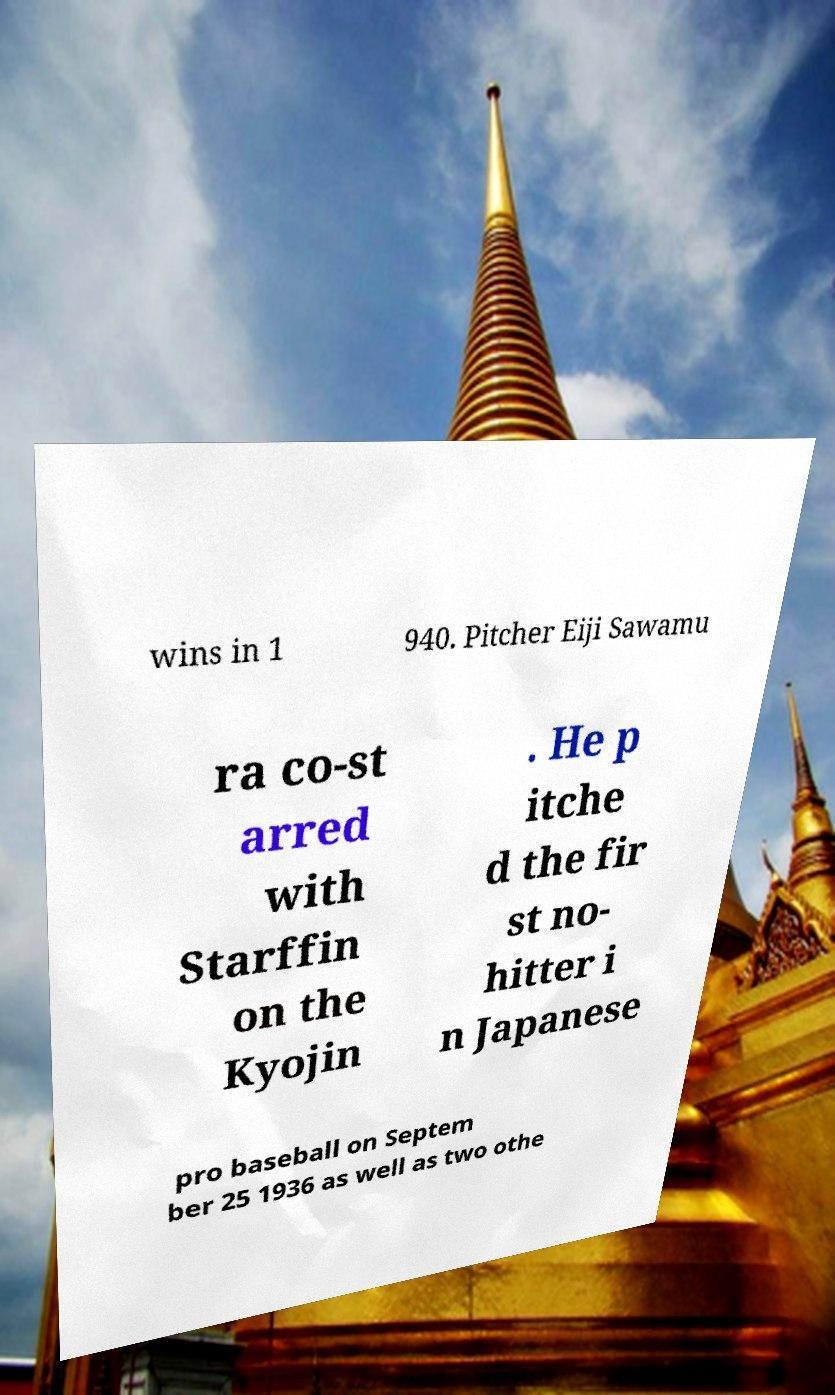There's text embedded in this image that I need extracted. Can you transcribe it verbatim? wins in 1 940. Pitcher Eiji Sawamu ra co-st arred with Starffin on the Kyojin . He p itche d the fir st no- hitter i n Japanese pro baseball on Septem ber 25 1936 as well as two othe 